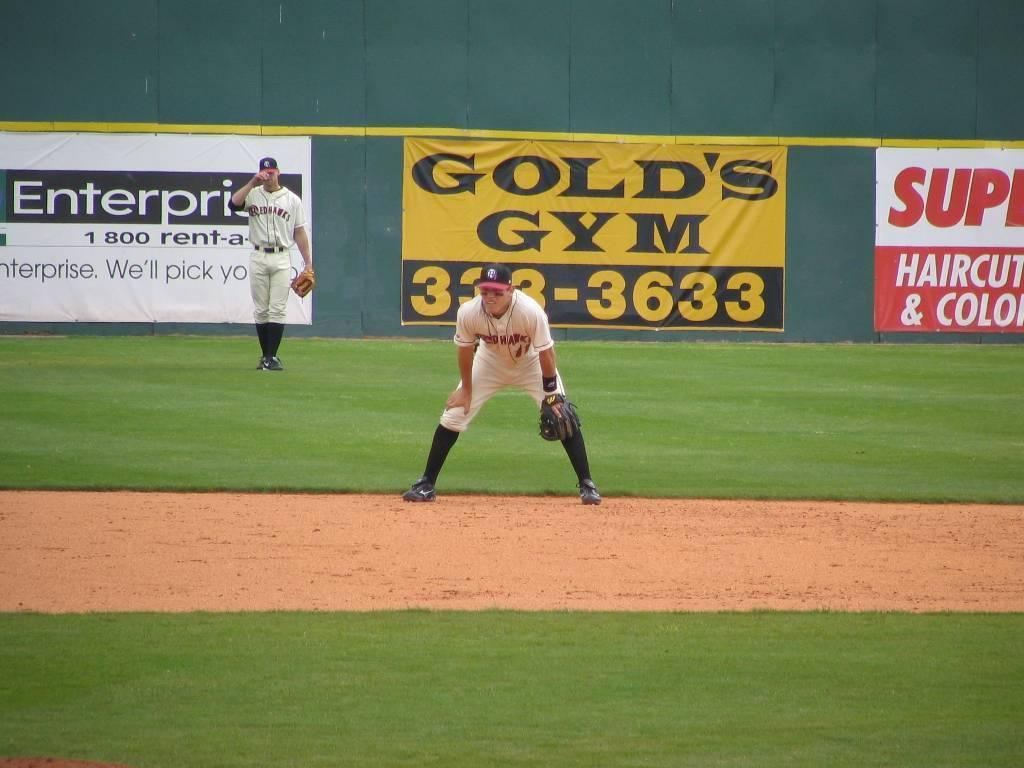Provide a one-sentence caption for the provided image. A man with the redhawks team crouches on a baseball field. 